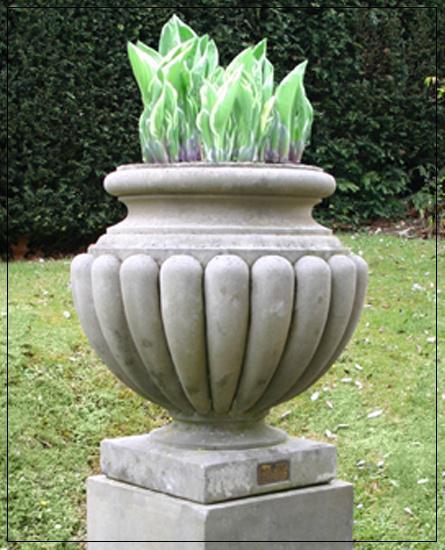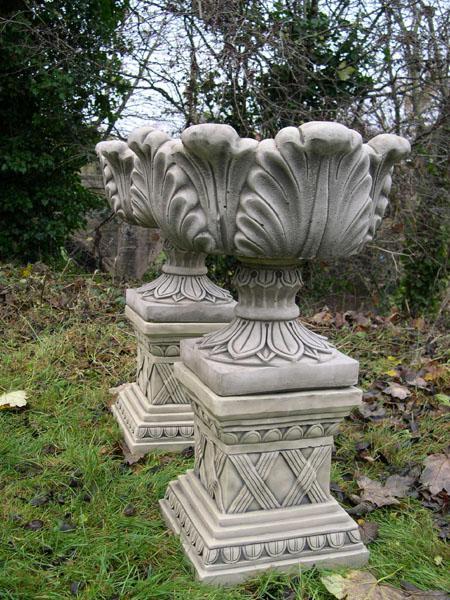The first image is the image on the left, the second image is the image on the right. Analyze the images presented: Is the assertion "All planters are grey stone-look material and sit on square pedestal bases, and at least one planter holds a plant," valid? Answer yes or no. Yes. The first image is the image on the left, the second image is the image on the right. Evaluate the accuracy of this statement regarding the images: "There are no more than three urns.". Is it true? Answer yes or no. Yes. 